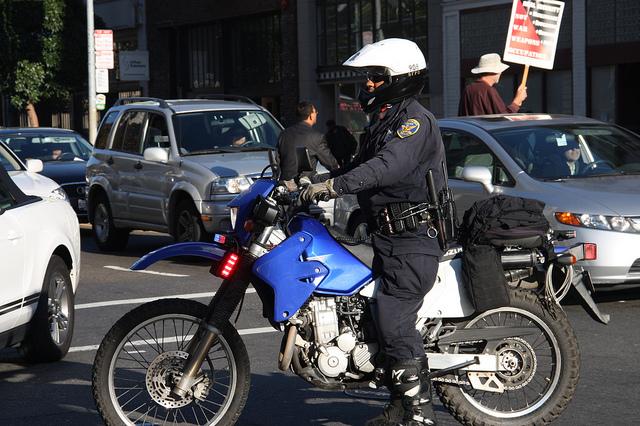Is the cop wearing a black helmet?
Give a very brief answer. No. What is in the picture?
Short answer required. Cop. What is the cop sitting on?
Give a very brief answer. Motorcycle. What is the color of the police bike?
Concise answer only. Blue. 